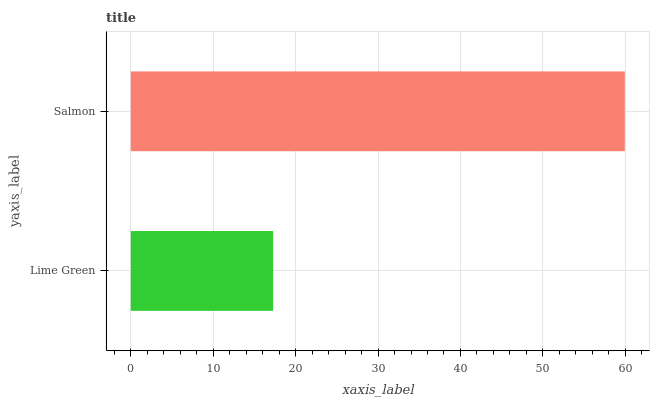Is Lime Green the minimum?
Answer yes or no. Yes. Is Salmon the maximum?
Answer yes or no. Yes. Is Salmon the minimum?
Answer yes or no. No. Is Salmon greater than Lime Green?
Answer yes or no. Yes. Is Lime Green less than Salmon?
Answer yes or no. Yes. Is Lime Green greater than Salmon?
Answer yes or no. No. Is Salmon less than Lime Green?
Answer yes or no. No. Is Salmon the high median?
Answer yes or no. Yes. Is Lime Green the low median?
Answer yes or no. Yes. Is Lime Green the high median?
Answer yes or no. No. Is Salmon the low median?
Answer yes or no. No. 